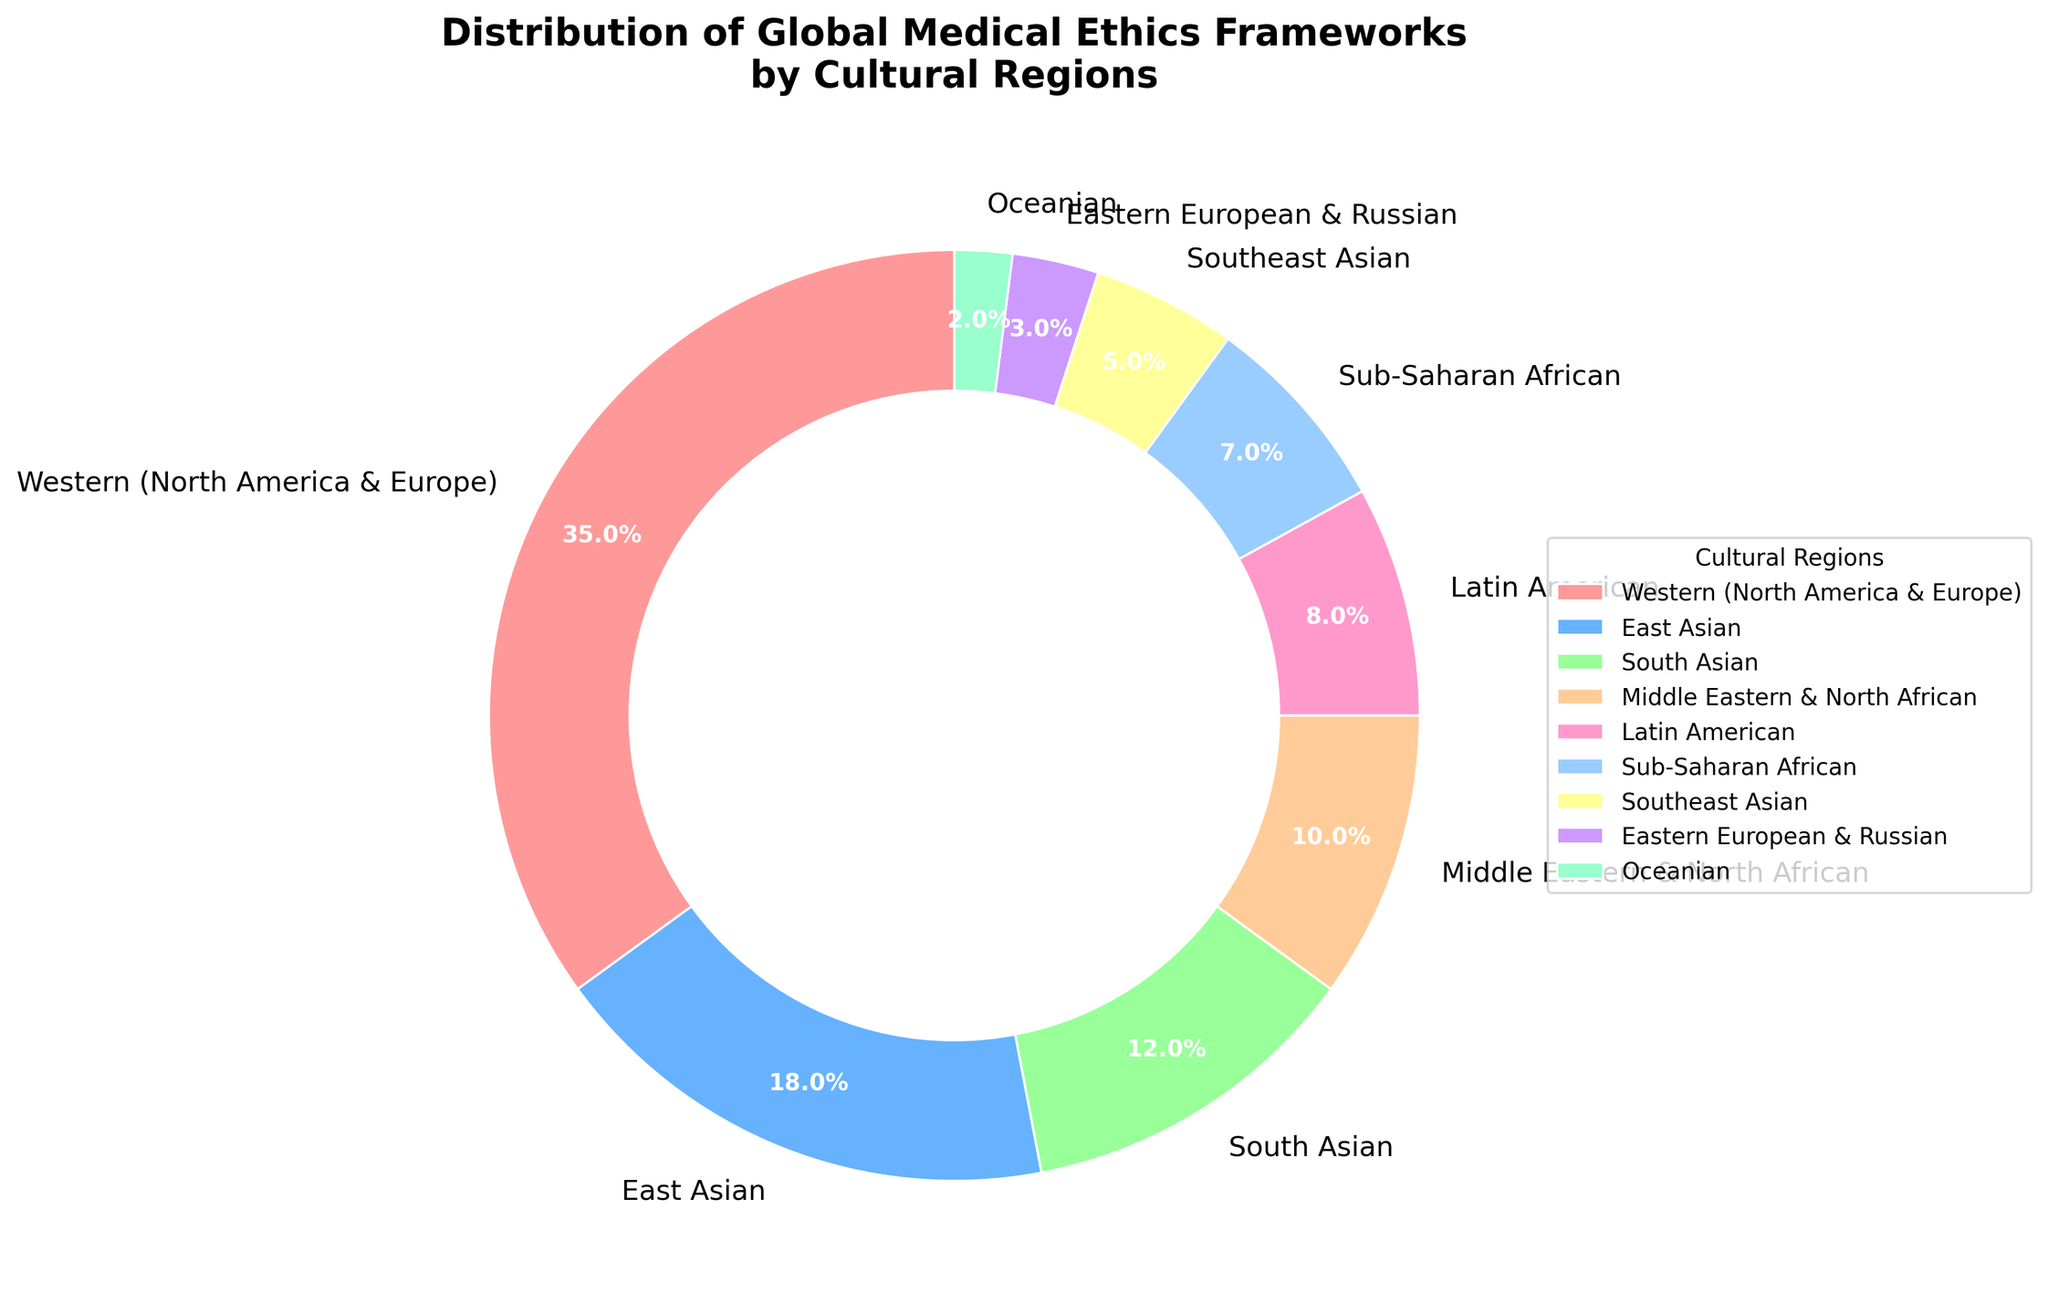What cultural regions have less than 10% representation in the global medical ethics frameworks? From the figure, the regions with less than 10% are Latin American, Sub-Saharan African, Southeast Asian, Eastern European & Russian, and Oceanian.
Answer: Latin American, Sub-Saharan African, Southeast Asian, Eastern European & Russian, Oceanian Which cultural region has the highest representation in the global medical ethics frameworks? The Western (North America & Europe) region has the largest portion of the pie chart, indicating it has the highest percentage.
Answer: Western (North America & Europe) What is the combined percentage of East Asian, South Asian, and Southeast Asian regions in the global medical ethics frameworks? Summing the percentages of East Asian (18%), South Asian (12%), and Southeast Asian (5%) gives 18 + 12 + 5 = 35%.
Answer: 35% How does the representation of the Middle Eastern & North African region compare with that of the Latin American region? The Middle Eastern & North African region has 10%, while the Latin American region has 8%. Comparing these, 10% is greater than 8%.
Answer: Greater Which regions have similar representation close to 10%? Middle Eastern & North African (10%) and Latin American (8%) are regions closely represented around 10%.
Answer: Middle Eastern & North African, Latin American What is the difference in representation between the Western and Eastern European & Russian regions? The Western region has 35%, and the Eastern European & Russian region has 3%. The difference is 35% - 3% = 32%.
Answer: 32% Identify the region with the smallest slice on the pie chart. The Oceanian region, with 2%, has the smallest slice on the pie chart.
Answer: Oceanian What is the average representation percentage of the Sub-Saharan African, Southeast Asian, and Oceanian regions? The percentages are: Sub-Saharan African (7%), Southeast Asian (5%), and Oceanian (2%). The sum is 7 + 5 + 2 = 14, and the average is 14 / 3 ≈ 4.67%.
Answer: 4.67% If you combine the percentages of Middle Eastern & North African and Sub-Saharan African regions, do they surpass Eastern European & Russian and Oceanian regions together? Combining their percentages, Middle Eastern & North African (10%) + Sub-Saharan African (7%) = 17%. Eastern European & Russian (3%) + Oceanian (2%) = 5%. Since 17% is more than 5%, they do surpass them.
Answer: Yes 